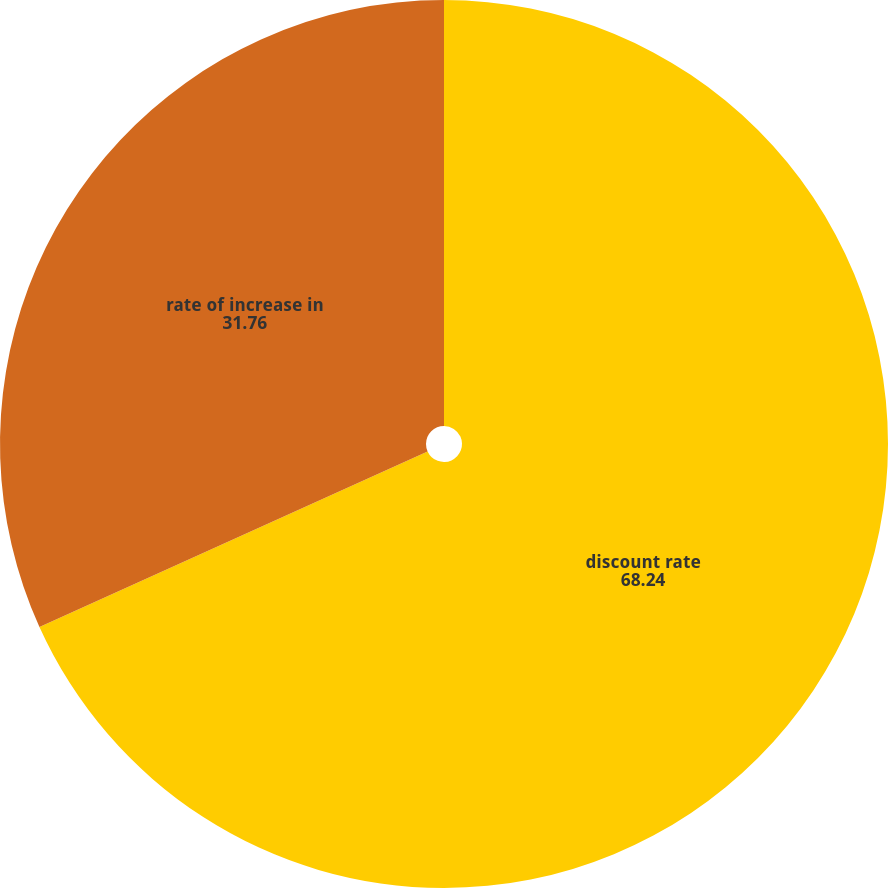<chart> <loc_0><loc_0><loc_500><loc_500><pie_chart><fcel>discount rate<fcel>rate of increase in<nl><fcel>68.24%<fcel>31.76%<nl></chart> 